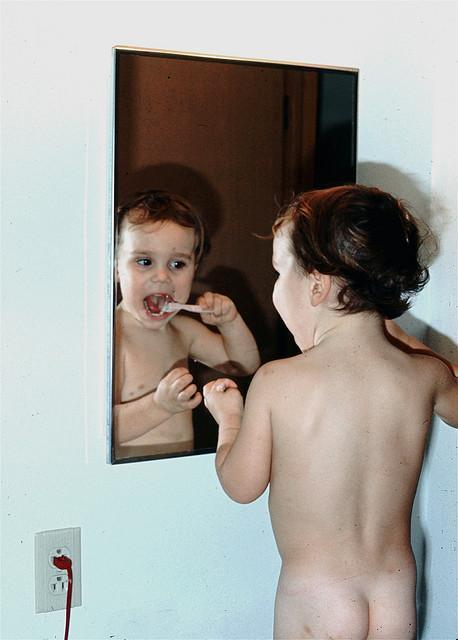How many people are there?
Give a very brief answer. 2. How many giraffes are there?
Give a very brief answer. 0. 